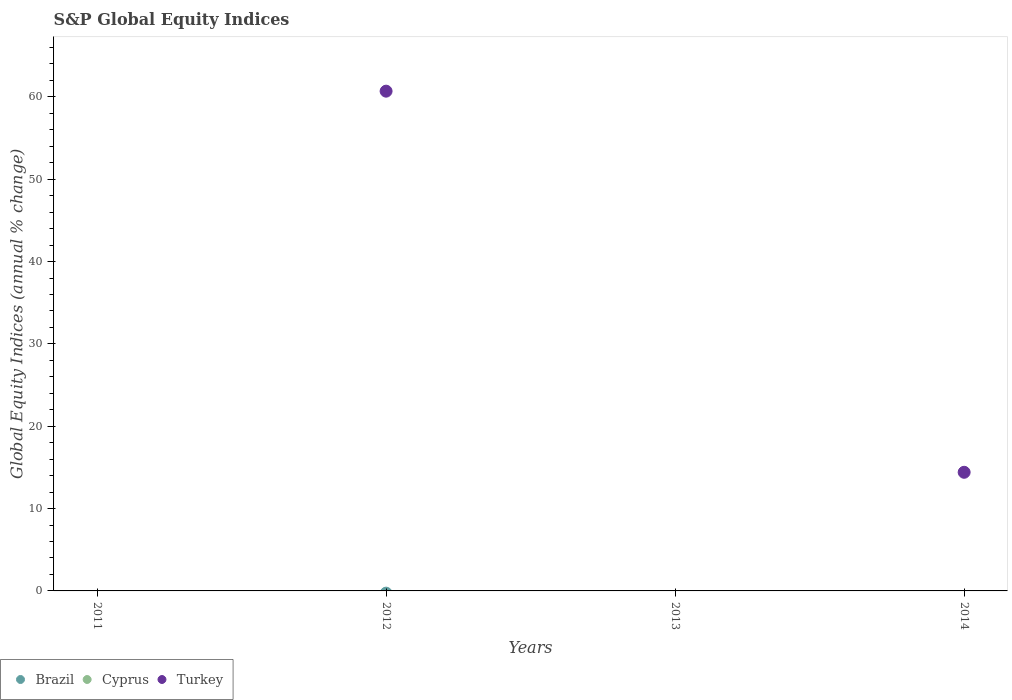Is the number of dotlines equal to the number of legend labels?
Provide a short and direct response. No. Across all years, what is the maximum global equity indices in Turkey?
Ensure brevity in your answer.  60.69. Across all years, what is the minimum global equity indices in Cyprus?
Give a very brief answer. 0. In which year was the global equity indices in Turkey maximum?
Provide a short and direct response. 2012. What is the total global equity indices in Brazil in the graph?
Keep it short and to the point. 0. What is the difference between the global equity indices in Turkey in 2011 and the global equity indices in Brazil in 2014?
Your response must be concise. 0. What is the average global equity indices in Turkey per year?
Offer a terse response. 18.77. In how many years, is the global equity indices in Brazil greater than 42 %?
Offer a very short reply. 0. What is the ratio of the global equity indices in Turkey in 2012 to that in 2014?
Ensure brevity in your answer.  4.21. What is the difference between the highest and the lowest global equity indices in Turkey?
Ensure brevity in your answer.  60.69. Is it the case that in every year, the sum of the global equity indices in Turkey and global equity indices in Brazil  is greater than the global equity indices in Cyprus?
Keep it short and to the point. No. Does the global equity indices in Brazil monotonically increase over the years?
Keep it short and to the point. No. Is the global equity indices in Turkey strictly greater than the global equity indices in Brazil over the years?
Keep it short and to the point. No. How many dotlines are there?
Your answer should be very brief. 1. How many years are there in the graph?
Your answer should be very brief. 4. What is the difference between two consecutive major ticks on the Y-axis?
Provide a short and direct response. 10. Are the values on the major ticks of Y-axis written in scientific E-notation?
Offer a terse response. No. What is the title of the graph?
Ensure brevity in your answer.  S&P Global Equity Indices. Does "Argentina" appear as one of the legend labels in the graph?
Offer a terse response. No. What is the label or title of the Y-axis?
Provide a succinct answer. Global Equity Indices (annual % change). What is the Global Equity Indices (annual % change) in Cyprus in 2011?
Your response must be concise. 0. What is the Global Equity Indices (annual % change) of Cyprus in 2012?
Your answer should be compact. 0. What is the Global Equity Indices (annual % change) of Turkey in 2012?
Provide a succinct answer. 60.69. What is the Global Equity Indices (annual % change) of Cyprus in 2013?
Provide a short and direct response. 0. What is the Global Equity Indices (annual % change) of Cyprus in 2014?
Give a very brief answer. 0. What is the Global Equity Indices (annual % change) in Turkey in 2014?
Make the answer very short. 14.41. Across all years, what is the maximum Global Equity Indices (annual % change) in Turkey?
Provide a short and direct response. 60.69. What is the total Global Equity Indices (annual % change) in Brazil in the graph?
Give a very brief answer. 0. What is the total Global Equity Indices (annual % change) of Turkey in the graph?
Provide a succinct answer. 75.1. What is the difference between the Global Equity Indices (annual % change) in Turkey in 2012 and that in 2014?
Offer a terse response. 46.28. What is the average Global Equity Indices (annual % change) of Brazil per year?
Your answer should be compact. 0. What is the average Global Equity Indices (annual % change) of Turkey per year?
Provide a short and direct response. 18.77. What is the ratio of the Global Equity Indices (annual % change) in Turkey in 2012 to that in 2014?
Make the answer very short. 4.21. What is the difference between the highest and the lowest Global Equity Indices (annual % change) of Turkey?
Ensure brevity in your answer.  60.69. 